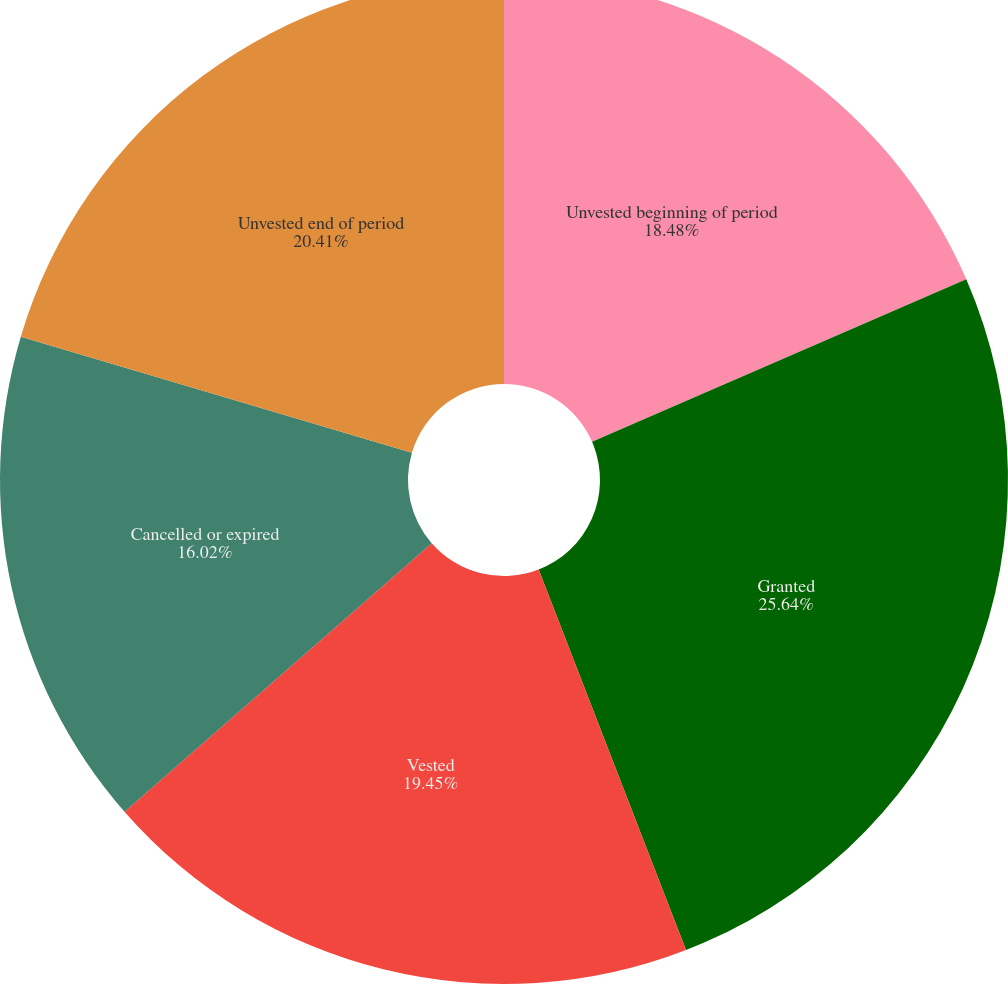Convert chart to OTSL. <chart><loc_0><loc_0><loc_500><loc_500><pie_chart><fcel>Unvested beginning of period<fcel>Granted<fcel>Vested<fcel>Cancelled or expired<fcel>Unvested end of period<nl><fcel>18.48%<fcel>25.64%<fcel>19.45%<fcel>16.02%<fcel>20.41%<nl></chart> 